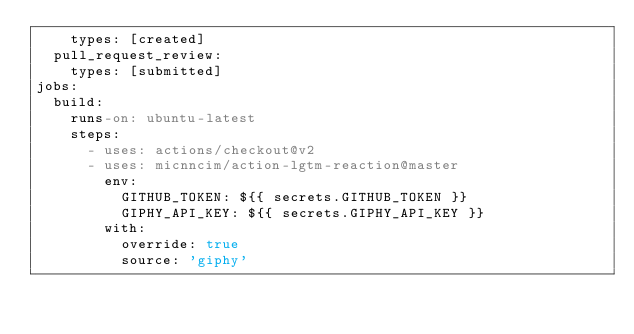<code> <loc_0><loc_0><loc_500><loc_500><_YAML_>    types: [created]
  pull_request_review:
    types: [submitted]
jobs:
  build:
    runs-on: ubuntu-latest
    steps:
      - uses: actions/checkout@v2
      - uses: micnncim/action-lgtm-reaction@master
        env:
          GITHUB_TOKEN: ${{ secrets.GITHUB_TOKEN }}
          GIPHY_API_KEY: ${{ secrets.GIPHY_API_KEY }}
        with:
          override: true
          source: 'giphy'
</code> 